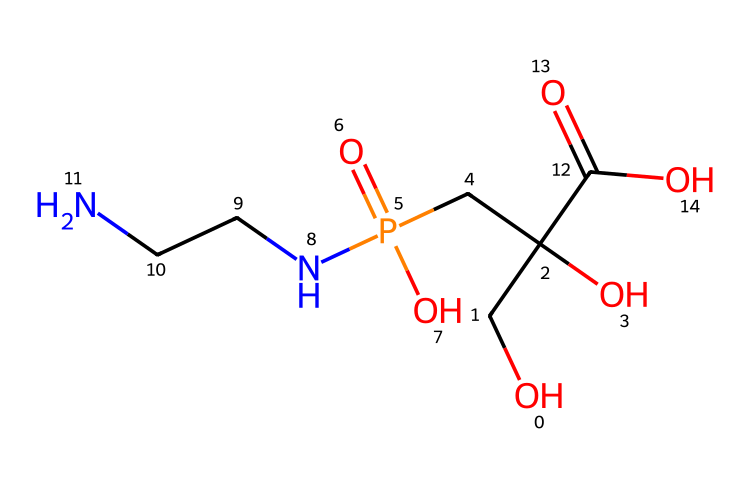How many carbon atoms are present in glyphosate? Examining the SMILES representation, we can count the 'C' characters which indicate carbon atoms. There are six 'C's in the structure.
Answer: six What is the total number of nitrogen atoms in the chemical structure? In the SMILES representation, we identify 'N' which denotes nitrogen atoms. There are two 'N's in the structure.
Answer: two What functional group is present at the end of the glyphosate structure? Looking at the ending part of the chemical, we see the 'C(=O)O' which indicates a carboxylic acid functional group (COOH).
Answer: carboxylic acid Is glyphosate a phosphorous-containing compound? The presence of 'P' in the SMILES indicates the inclusion of phosphorus in the structure, confirming that it does contain phosphorous.
Answer: yes What is the significance of the 'P(=O)(O)' portion in the chemical? This indicates that phosphorus is in a phosphate group, suggesting that it plays an important role in glyphosate's mode of action as a herbicide, affecting plant metabolic pathways.
Answer: phosphate group How many oxygen atoms are part of glyphosate? By counting the 'O' in the SMILES, we find there are four 'O's listed, which indicates four oxygen atoms are present in the structure.
Answer: four What type of chemical is glyphosate classified as? Considering its structure and functional groups, glyphosate is classified as a systemic herbicide used in agriculture for weed control.
Answer: herbicide 